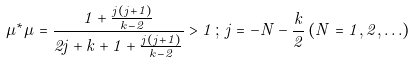<formula> <loc_0><loc_0><loc_500><loc_500>\mu ^ { * } \mu = \frac { 1 + \frac { j ( j + 1 ) } { k - 2 } } { 2 j + k + 1 + \frac { j ( j + 1 ) } { k - 2 } } > 1 \, ; \, j = - N - \frac { k } { 2 } \, ( N = { 1 , 2 , \dots } )</formula> 